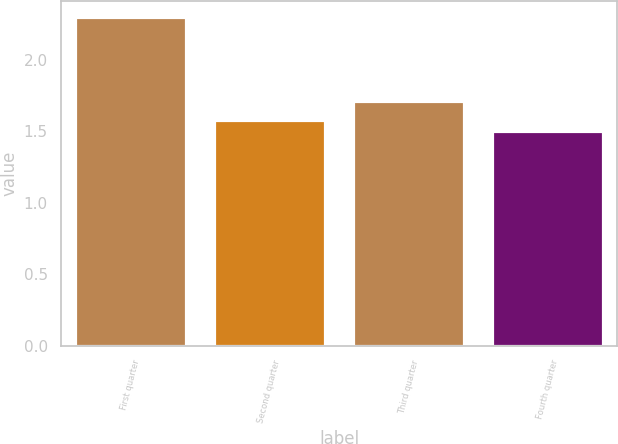Convert chart to OTSL. <chart><loc_0><loc_0><loc_500><loc_500><bar_chart><fcel>First quarter<fcel>Second quarter<fcel>Third quarter<fcel>Fourth quarter<nl><fcel>2.3<fcel>1.58<fcel>1.71<fcel>1.5<nl></chart> 